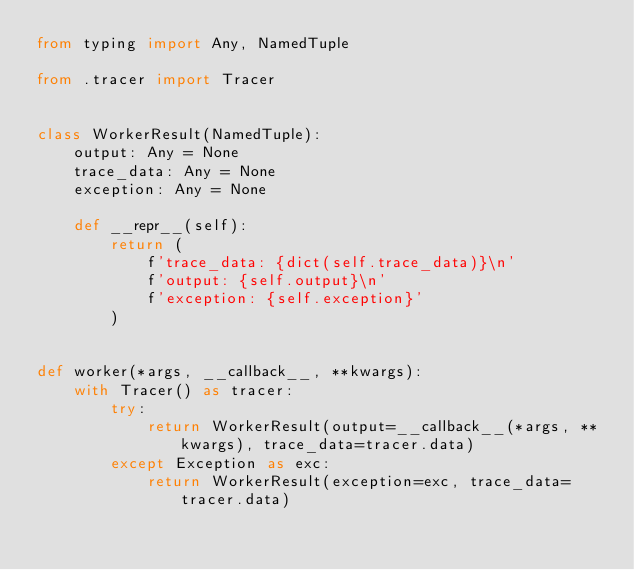<code> <loc_0><loc_0><loc_500><loc_500><_Python_>from typing import Any, NamedTuple

from .tracer import Tracer


class WorkerResult(NamedTuple):
    output: Any = None
    trace_data: Any = None
    exception: Any = None

    def __repr__(self):
        return (
            f'trace_data: {dict(self.trace_data)}\n'
            f'output: {self.output}\n'
            f'exception: {self.exception}'
        )


def worker(*args, __callback__, **kwargs):
    with Tracer() as tracer:
        try:
            return WorkerResult(output=__callback__(*args, **kwargs), trace_data=tracer.data)
        except Exception as exc:
            return WorkerResult(exception=exc, trace_data=tracer.data)
</code> 